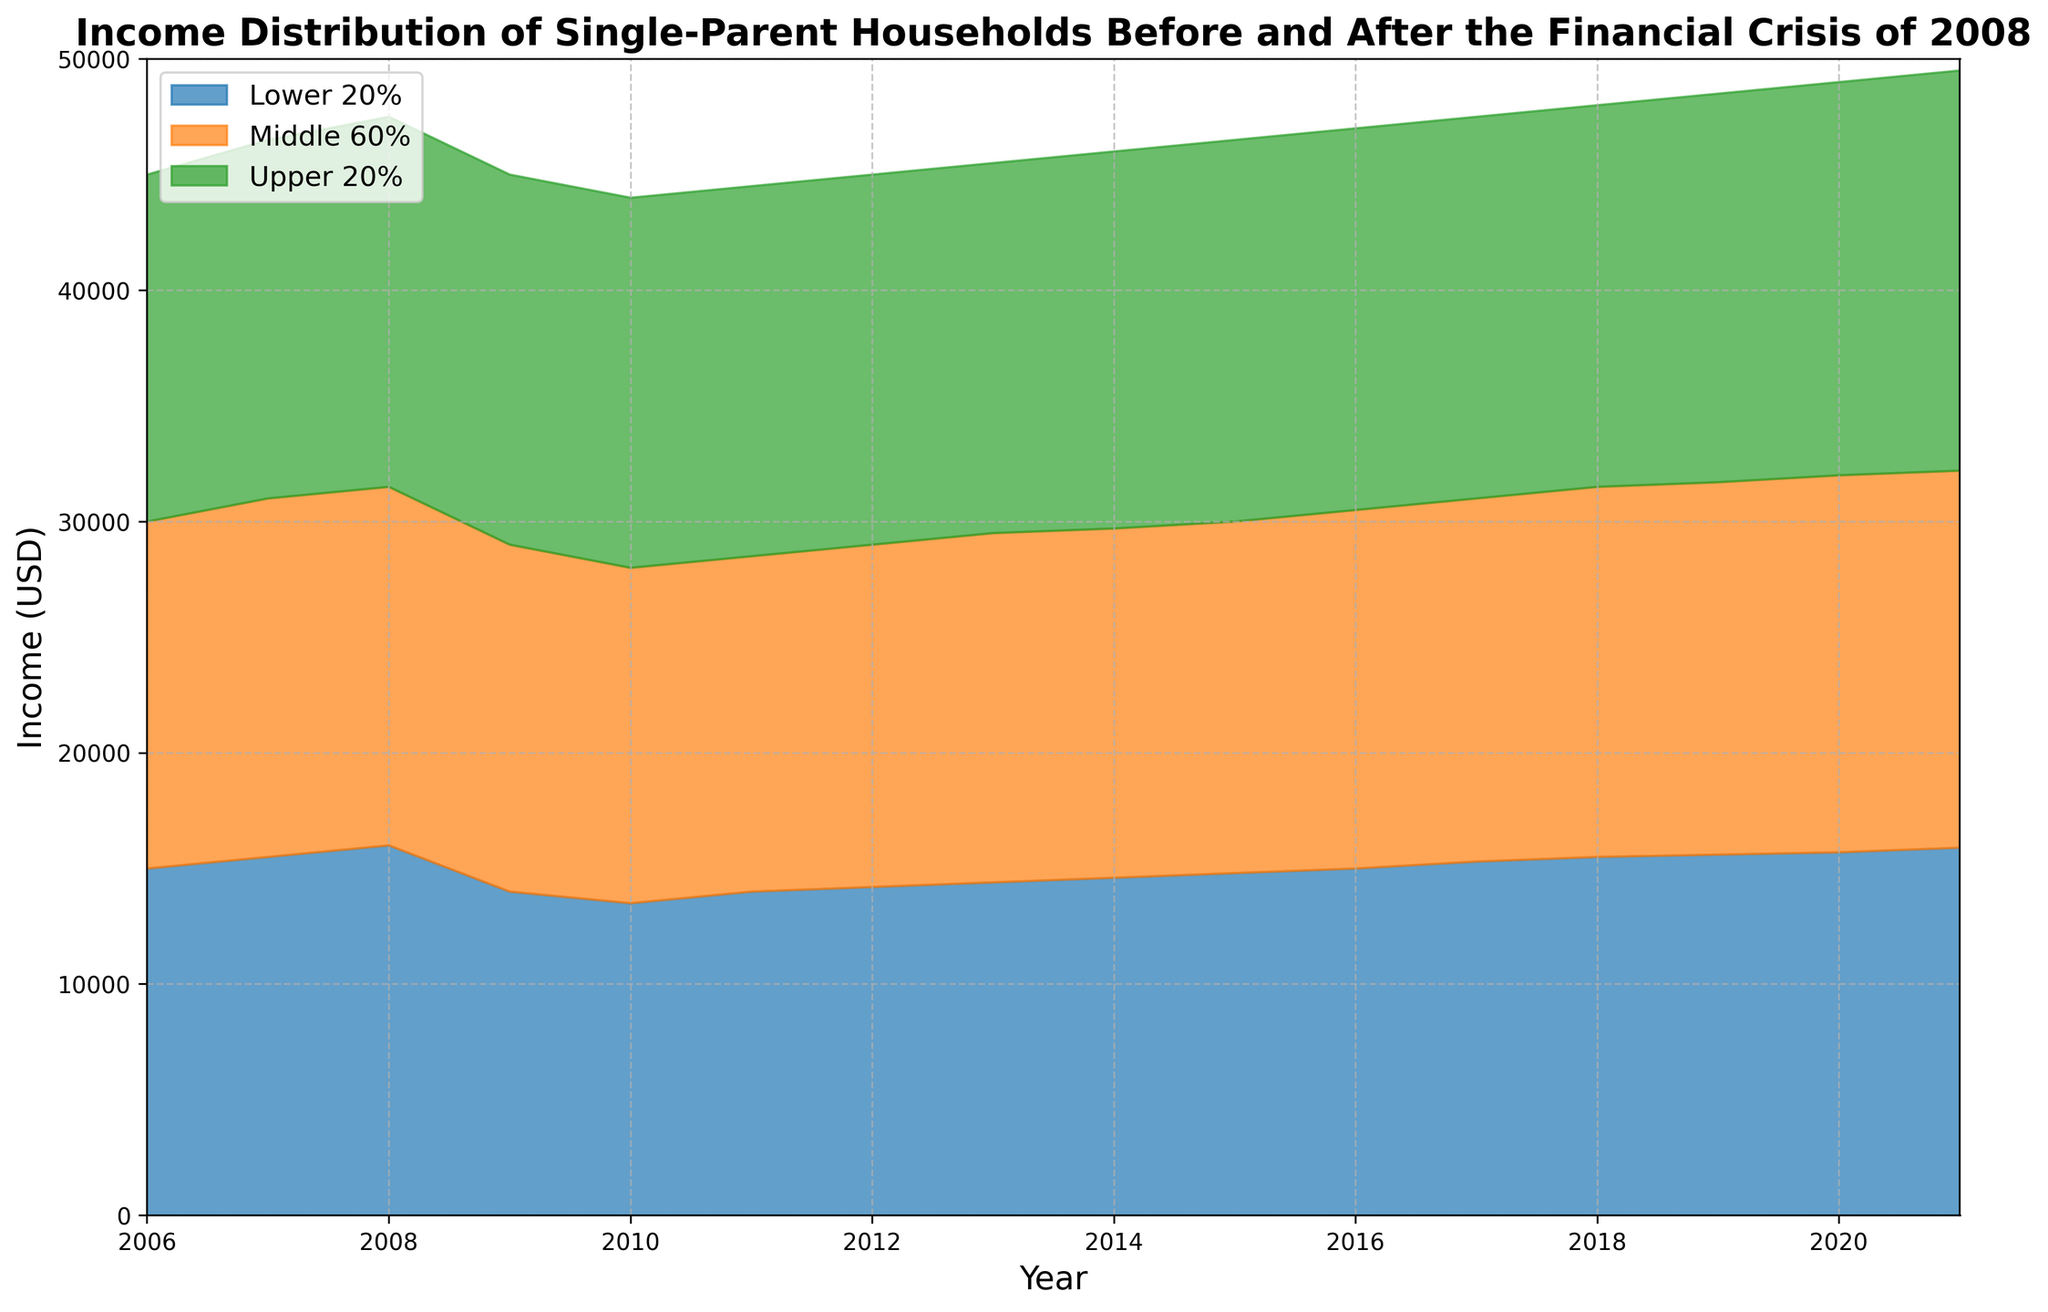What was the income for the lower 20% of single-parent households in 2008 and 2009? In the chart, look at the year 2008 under the lower 20% layer, the income value is 16,000 USD. For 2009, it is 14,000 USD.
Answer: 16,000 USD in 2008, 14,000 USD in 2009 How did the income of the upper 20% of single-parent households change from 2007 to 2009? Check the difference between 2007 and 2009 for the upper 20% layer. It was 46,500 USD in 2007 and dropped to 45,000 USD in 2009. The change is 46,500 - 45,000 = -1,500 USD.
Answer: Decreased by 1,500 USD During which year did the middle 60% of single-parent households see the lowest income? Examine the middle 60% layers in the chart between 2006 and 2021. The lowest value occurred in 2010, at 28,000 USD.
Answer: 2010 What is the trend for the lower 20% income of single-parent households from 2006 to 2021? Follow the lower 20% layer from 2006 to 2021. Observe it generally decreases during 2009-2010 and then gradually increases until 2021, indicating an overall upward trend despite the dip around the financial crisis.
Answer: Increasing trend with a dip By how much did the income of the middle 60% single-parent households change from 2008 to 2021? Locate the middle 60% income for 2008 (31,500 USD) and 2021 (32,200 USD) on the chart. The change is 32,200 - 31,500 = 700 USD.
Answer: Increased by 700 USD Which group experienced the least income decline during the financial crisis (2008-2010)? Compare the income drop from 2008 to 2010 for all groups. Lower 20% dropped from 16,000 to 13,500 USD, middle 60% dropped from 31,500 to 28,000 USD, and upper 20% dropped from 47,500 to 44,000 USD. The smallest decline is for the upper 20%: 47,500 - 44,000 = 3,500 USD.
Answer: Upper 20% How does the income gap between the lower 20% and upper 20% single-parent households in 2021 compare to that in 2006? In 2006, the gap is 45,000 - 15,000 = 30,000 USD. In 2021, the gap is 49,500 - 15,900 = 33,600 USD.
Answer: Increased by 3,600 USD Which group had the highest income throughout the dataset period? Look at the upper layers consistently across the chart. The highest income throughout is always in the upper 20% group.
Answer: Upper 20% What was the income trend for the middle 60% single-parent households before and after 2008? Before 2008, the income increased yearly until 2008. After 2008, it declined during 2009-2010, then steadily increased again until 2021.
Answer: Increasing before and after a decline Which layer is represented in orange? Identify the color scheme from the legend. The orange layer is labeled as the middle 60%.
Answer: Middle 60% 